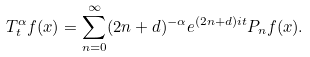<formula> <loc_0><loc_0><loc_500><loc_500>T _ { t } ^ { \alpha } f ( x ) = \sum _ { n = 0 } ^ { \infty } ( 2 n + d ) ^ { - \alpha } e ^ { ( 2 n + d ) i t } P _ { n } f ( x ) .</formula> 